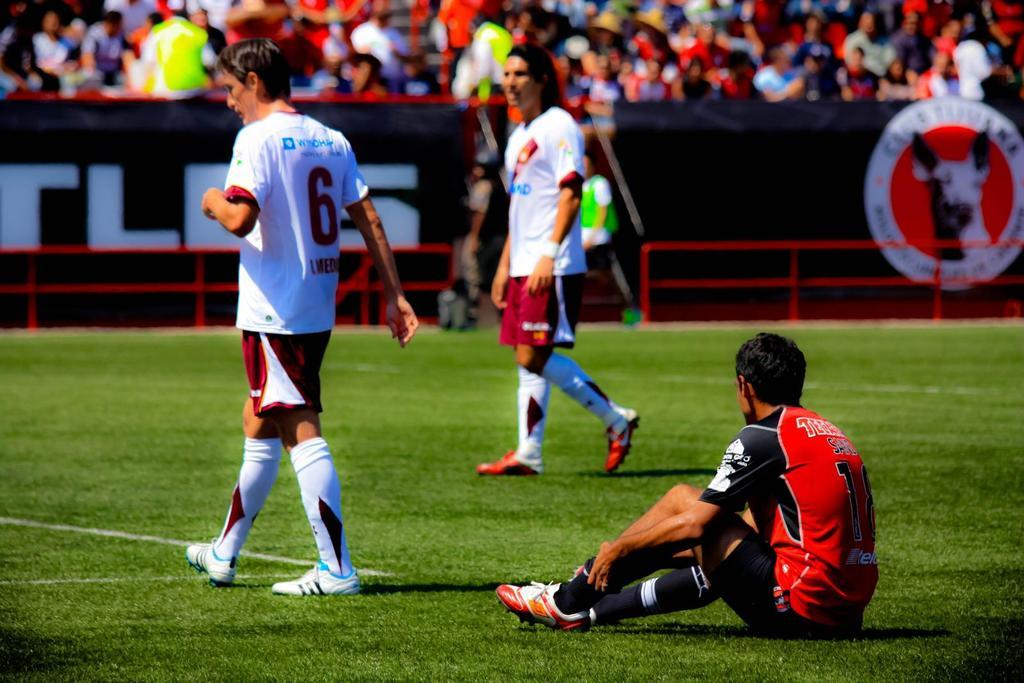What is the man in the image doing? There is a man sitting in the image. How many other men are in the image? There are two men standing in the image. What can be seen in the background of the image? There are people and a fence visible in the background of the image. What type of vegetation is present in the background of the image? There is grass visible in the background of the image. What is the price of the request made by the father in the image? There is no mention of a request or a father in the image, so it is not possible to determine the price of any request. 